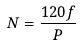Convert formula to latex. <formula><loc_0><loc_0><loc_500><loc_500>N = \frac { 1 2 0 f } { P }</formula> 